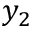<formula> <loc_0><loc_0><loc_500><loc_500>y _ { 2 }</formula> 